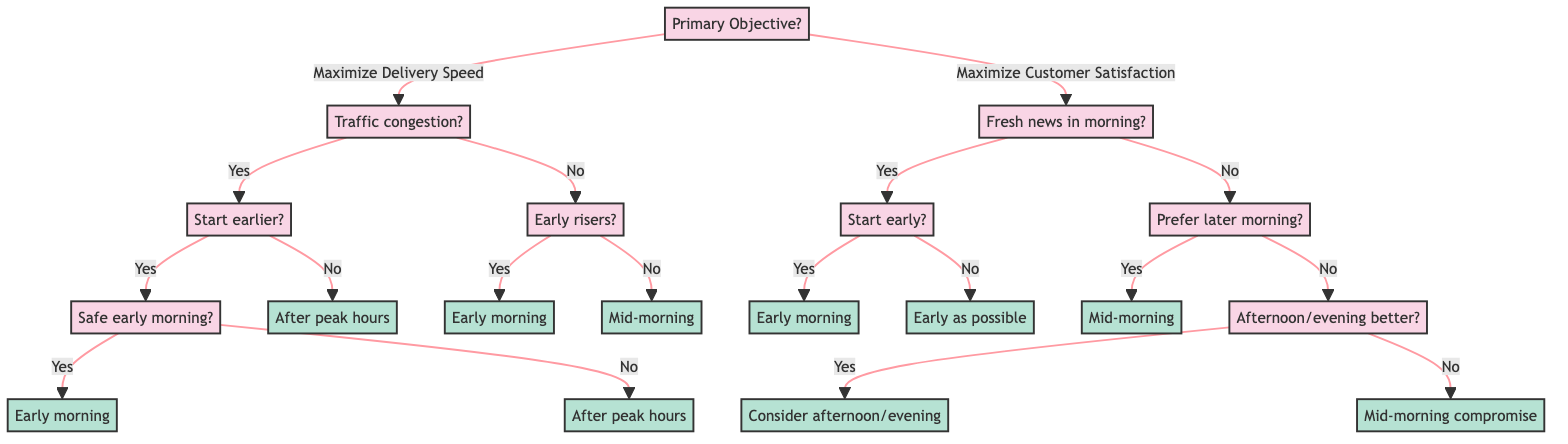What is the primary objective of the decision tree? The diagram starts with a root node asking for the primary objective, presenting two options: "Maximize Delivery Speed" and "Maximize Customer Satisfaction".
Answer: Maximize Delivery Speed or Maximize Customer Satisfaction How many major nodes are there in the decision tree? The diagram has two major branches stemming from the primary objective, which are "Maximize Delivery Speed" and "Maximize Customer Satisfaction". Therefore, there are a total of two major nodes.
Answer: 2 What is the result if customers prefer fresh news in the morning, but the delivery person cannot start deliveries early? Following the path from the node indicating customers prefer fresh news, if the delivery person cannot start early, the next step states to deliver as early as possible within constraints.
Answer: Deliver as early as possible within your constraints If traffic congestion is not a concern, what should the delivery person consider regarding early risers? From the "Traffic congestion" node that indicates no, the decision goes to whether the majority of the client base are early risers or not. If they are not early risers, the recommendation is to deliver mid-morning.
Answer: Mid-morning What should the delivery person do if they can start deliveries earlier, but the neighborhood is not safe early in the morning? Starting from the "Traffic congestion" node with "Yes" and the next node asking if they can start early but the safety question indicates "No", the result advises to consider starting deliveries after peak traffic hours.
Answer: Consider starting deliveries after peak traffic hours What is the outcome if customers prefer receiving newspapers later in the morning and the delivery person cannot provide afternoon or evening delivery? If the customers prefer later morning and the person cannot deliver in the afternoon or evening, one should follow the path leading to the conclusion of "Mid-morning deliveries may be the best compromise".
Answer: Mid-morning deliveries may be the best compromise What action should be taken if the neighborhood is safe early in the morning and the delivery person can start deliveries earlier with traffic congestion? Initially, starting with the "Yes" to being able to start deliveries early and then determining the neighborhood is safe leads directly to the conclusion of starting deliveries early in the morning.
Answer: Start deliveries early in the morning Which option is recommended if customers do not prefer fresh news in the morning and prefer receiving newspapers later? The decision tree will lead from "customers prefer later in the morning" to adding a question about afternoon or evening deliveries. If they prefer later and can't do afternoon, that's the path to "Mid-morning compromise".
Answer: Mid-morning compromise 